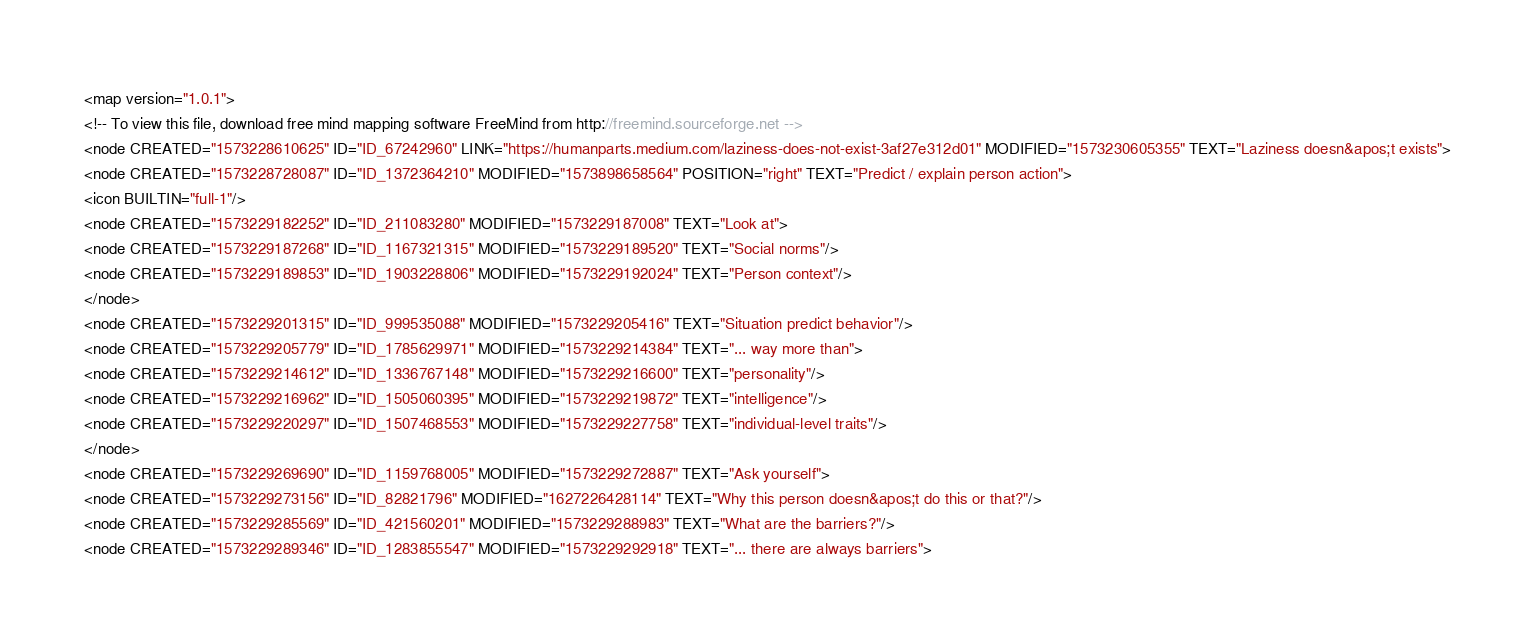Convert code to text. <code><loc_0><loc_0><loc_500><loc_500><_ObjectiveC_><map version="1.0.1">
<!-- To view this file, download free mind mapping software FreeMind from http://freemind.sourceforge.net -->
<node CREATED="1573228610625" ID="ID_67242960" LINK="https://humanparts.medium.com/laziness-does-not-exist-3af27e312d01" MODIFIED="1573230605355" TEXT="Laziness doesn&apos;t exists">
<node CREATED="1573228728087" ID="ID_1372364210" MODIFIED="1573898658564" POSITION="right" TEXT="Predict / explain person action">
<icon BUILTIN="full-1"/>
<node CREATED="1573229182252" ID="ID_211083280" MODIFIED="1573229187008" TEXT="Look at">
<node CREATED="1573229187268" ID="ID_1167321315" MODIFIED="1573229189520" TEXT="Social norms"/>
<node CREATED="1573229189853" ID="ID_1903228806" MODIFIED="1573229192024" TEXT="Person context"/>
</node>
<node CREATED="1573229201315" ID="ID_999535088" MODIFIED="1573229205416" TEXT="Situation predict behavior"/>
<node CREATED="1573229205779" ID="ID_1785629971" MODIFIED="1573229214384" TEXT="... way more than">
<node CREATED="1573229214612" ID="ID_1336767148" MODIFIED="1573229216600" TEXT="personality"/>
<node CREATED="1573229216962" ID="ID_1505060395" MODIFIED="1573229219872" TEXT="intelligence"/>
<node CREATED="1573229220297" ID="ID_1507468553" MODIFIED="1573229227758" TEXT="individual-level traits"/>
</node>
<node CREATED="1573229269690" ID="ID_1159768005" MODIFIED="1573229272887" TEXT="Ask yourself">
<node CREATED="1573229273156" ID="ID_82821796" MODIFIED="1627226428114" TEXT="Why this person doesn&apos;t do this or that?"/>
<node CREATED="1573229285569" ID="ID_421560201" MODIFIED="1573229288983" TEXT="What are the barriers?"/>
<node CREATED="1573229289346" ID="ID_1283855547" MODIFIED="1573229292918" TEXT="... there are always barriers"></code> 